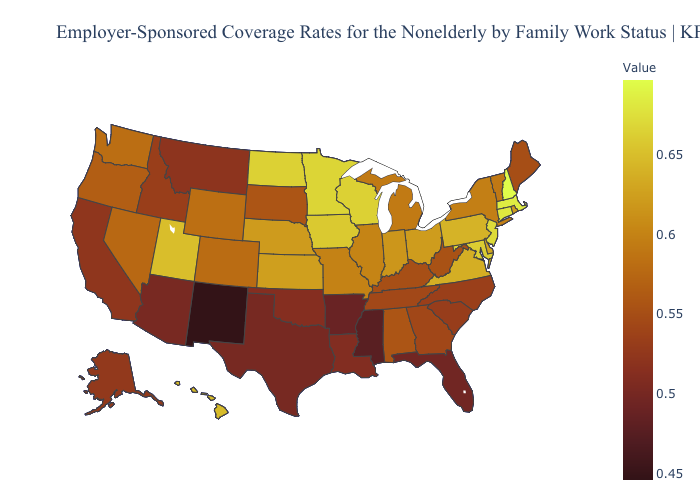Which states have the highest value in the USA?
Concise answer only. New Hampshire. Does Oregon have a lower value than South Carolina?
Be succinct. No. Among the states that border California , does Arizona have the lowest value?
Short answer required. Yes. Does South Dakota have the lowest value in the MidWest?
Quick response, please. Yes. Among the states that border New Mexico , which have the lowest value?
Quick response, please. Texas. 